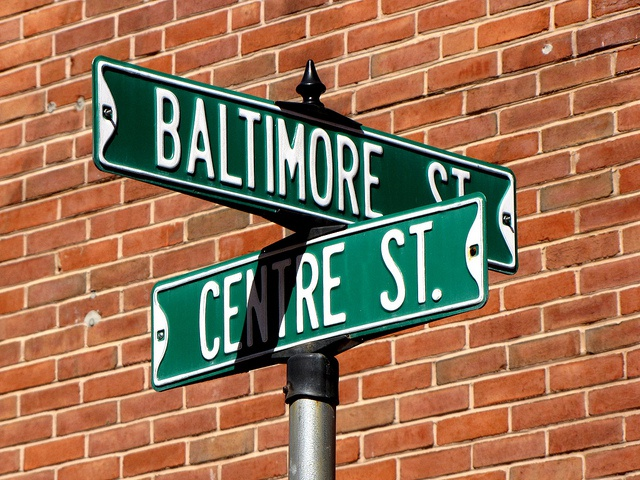Describe the objects in this image and their specific colors. I can see various objects in this image with different colors. 